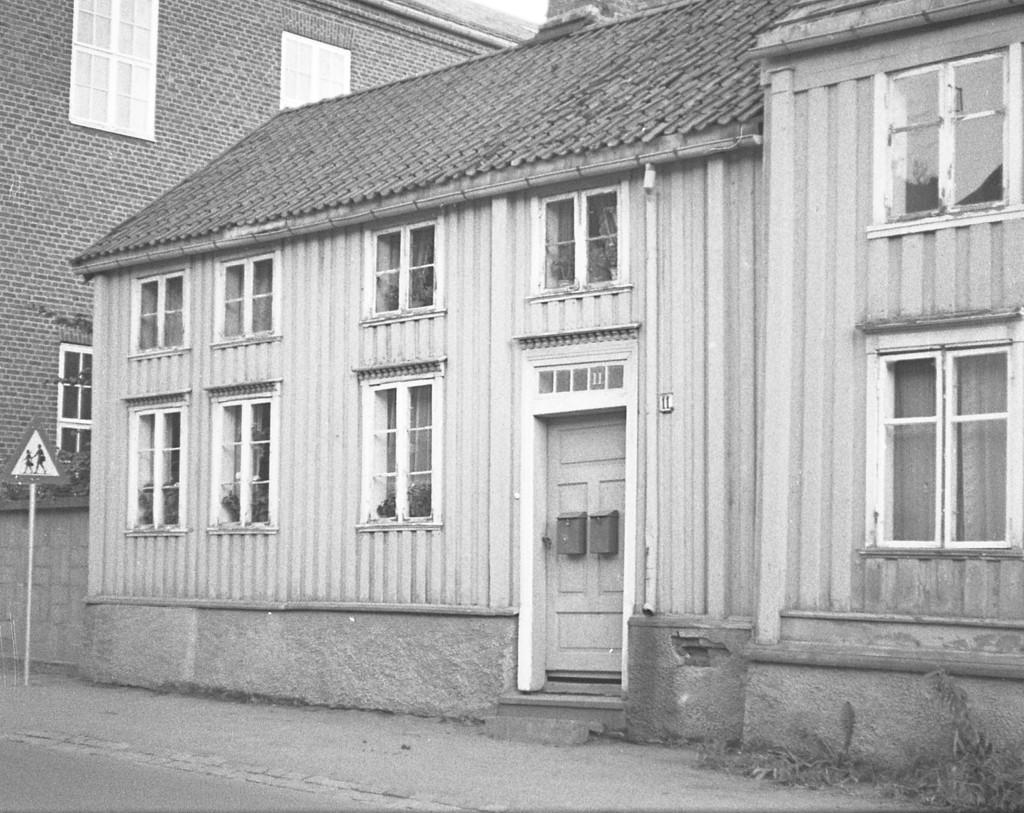Can you describe this image briefly? House with windows and door. Here we can see a signboard. 